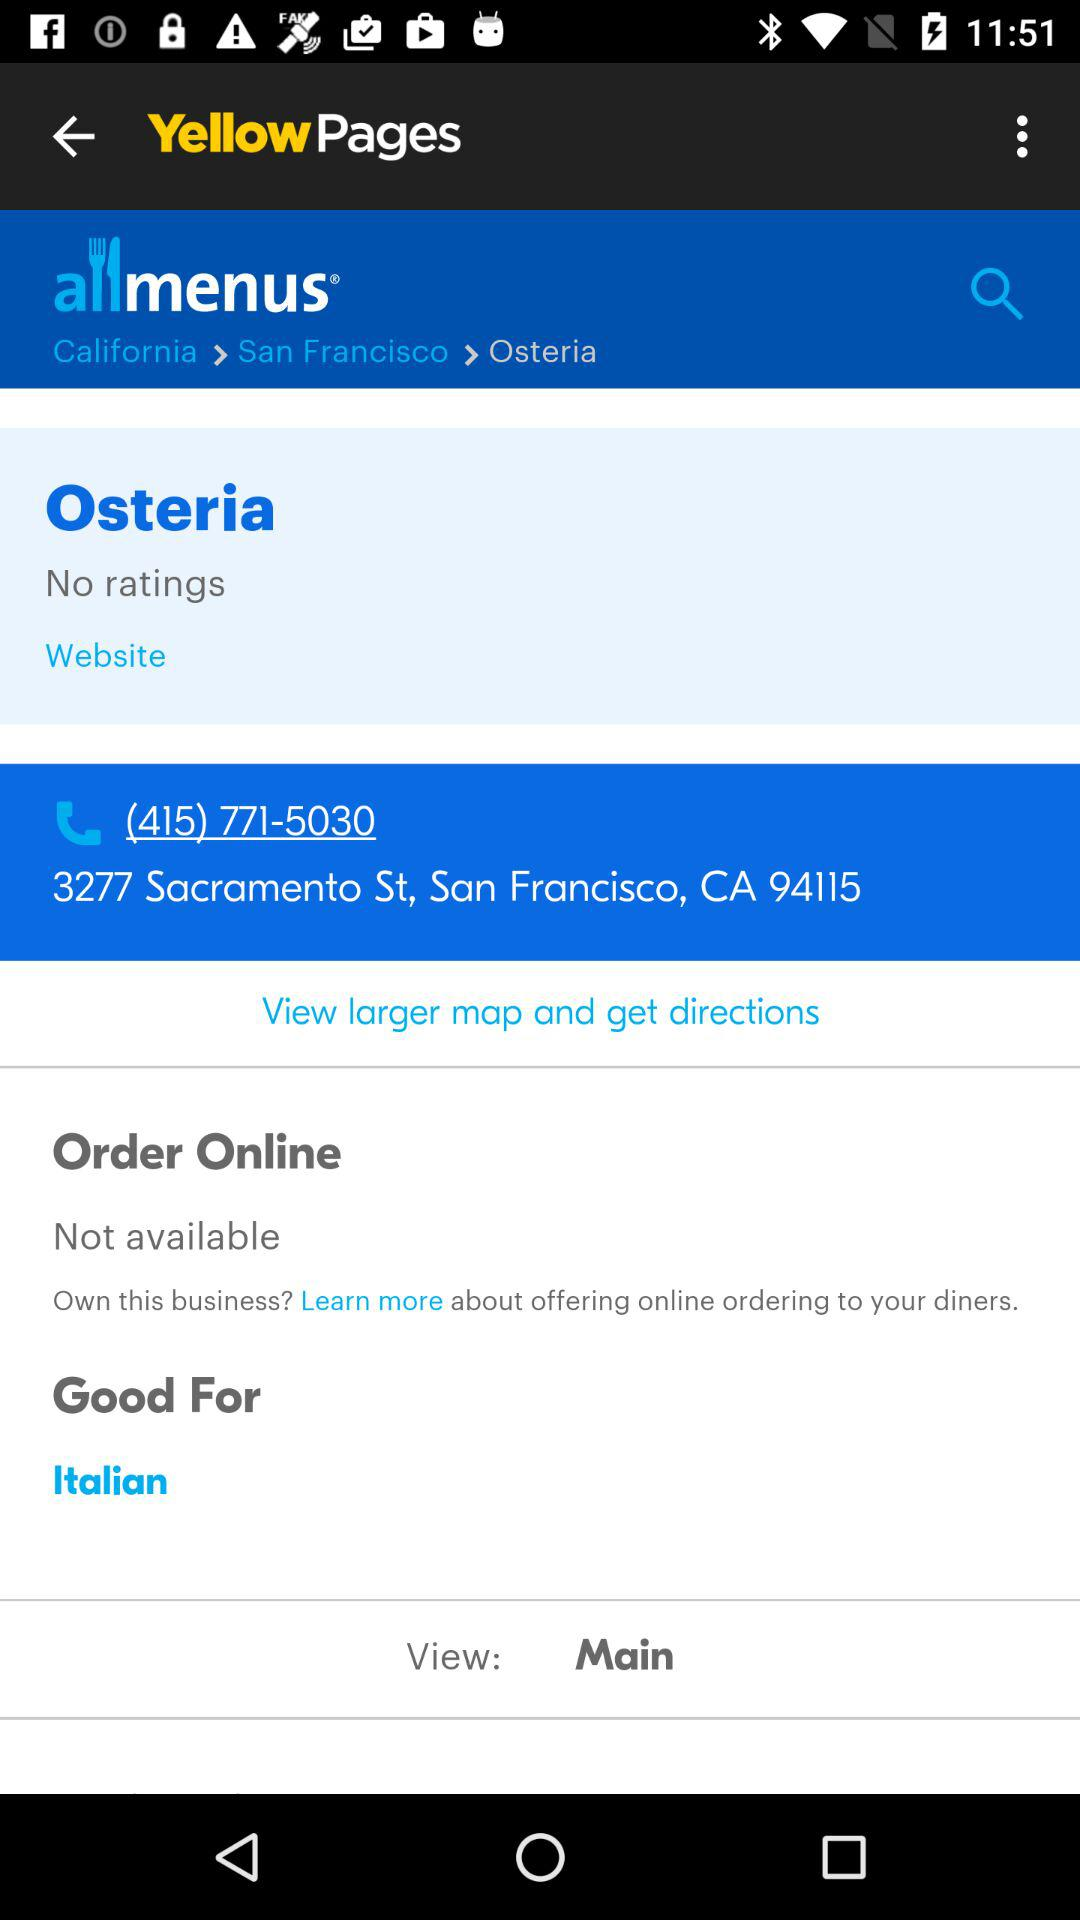What is the location? The location is 3277 Sacramento St, San Francisco, CA 94115. 